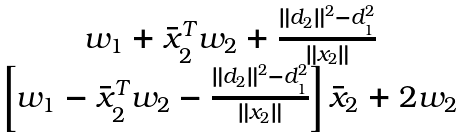<formula> <loc_0><loc_0><loc_500><loc_500>\begin{matrix} w _ { 1 } + \bar { x } _ { 2 } ^ { T } w _ { 2 } + \frac { \| d _ { 2 } \| ^ { 2 } - d _ { 1 } ^ { 2 } } { \| x _ { 2 } \| } \\ \left [ w _ { 1 } - \bar { x } _ { 2 } ^ { T } w _ { 2 } - \frac { \| d _ { 2 } \| ^ { 2 } - d _ { 1 } ^ { 2 } } { \| x _ { 2 } \| } \right ] \bar { x } _ { 2 } + 2 w _ { 2 } \end{matrix}</formula> 